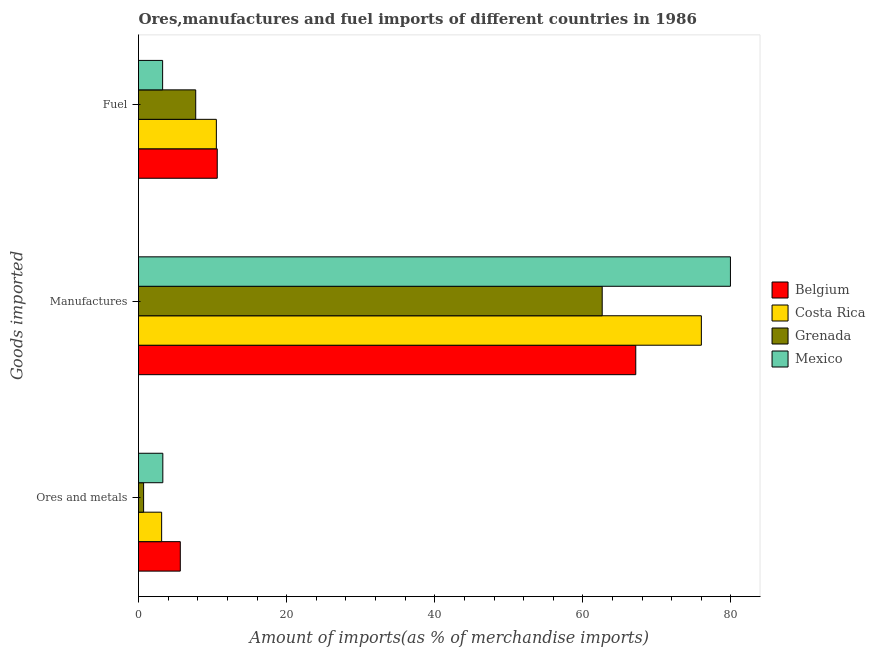Are the number of bars per tick equal to the number of legend labels?
Your response must be concise. Yes. How many bars are there on the 3rd tick from the top?
Provide a succinct answer. 4. How many bars are there on the 3rd tick from the bottom?
Your answer should be very brief. 4. What is the label of the 3rd group of bars from the top?
Keep it short and to the point. Ores and metals. What is the percentage of manufactures imports in Mexico?
Your answer should be very brief. 79.93. Across all countries, what is the maximum percentage of ores and metals imports?
Your answer should be very brief. 5.64. Across all countries, what is the minimum percentage of fuel imports?
Ensure brevity in your answer.  3.26. In which country was the percentage of fuel imports maximum?
Provide a succinct answer. Belgium. What is the total percentage of ores and metals imports in the graph?
Ensure brevity in your answer.  12.74. What is the difference between the percentage of ores and metals imports in Costa Rica and that in Grenada?
Make the answer very short. 2.44. What is the difference between the percentage of fuel imports in Belgium and the percentage of ores and metals imports in Mexico?
Offer a very short reply. 7.35. What is the average percentage of manufactures imports per country?
Offer a terse response. 71.42. What is the difference between the percentage of ores and metals imports and percentage of manufactures imports in Belgium?
Your answer should be compact. -61.5. In how many countries, is the percentage of ores and metals imports greater than 56 %?
Provide a short and direct response. 0. What is the ratio of the percentage of manufactures imports in Costa Rica to that in Belgium?
Your response must be concise. 1.13. Is the percentage of manufactures imports in Mexico less than that in Costa Rica?
Provide a short and direct response. No. Is the difference between the percentage of fuel imports in Belgium and Grenada greater than the difference between the percentage of manufactures imports in Belgium and Grenada?
Ensure brevity in your answer.  No. What is the difference between the highest and the second highest percentage of manufactures imports?
Offer a very short reply. 3.93. What is the difference between the highest and the lowest percentage of fuel imports?
Your response must be concise. 7.38. What does the 4th bar from the top in Manufactures represents?
Your answer should be compact. Belgium. How many countries are there in the graph?
Ensure brevity in your answer.  4. What is the difference between two consecutive major ticks on the X-axis?
Your response must be concise. 20. Are the values on the major ticks of X-axis written in scientific E-notation?
Provide a succinct answer. No. Does the graph contain any zero values?
Your answer should be compact. No. Where does the legend appear in the graph?
Make the answer very short. Center right. How many legend labels are there?
Provide a short and direct response. 4. What is the title of the graph?
Your answer should be compact. Ores,manufactures and fuel imports of different countries in 1986. Does "Liberia" appear as one of the legend labels in the graph?
Your answer should be very brief. No. What is the label or title of the X-axis?
Keep it short and to the point. Amount of imports(as % of merchandise imports). What is the label or title of the Y-axis?
Make the answer very short. Goods imported. What is the Amount of imports(as % of merchandise imports) of Belgium in Ores and metals?
Your answer should be compact. 5.64. What is the Amount of imports(as % of merchandise imports) in Costa Rica in Ores and metals?
Offer a very short reply. 3.12. What is the Amount of imports(as % of merchandise imports) of Grenada in Ores and metals?
Your response must be concise. 0.69. What is the Amount of imports(as % of merchandise imports) of Mexico in Ores and metals?
Ensure brevity in your answer.  3.28. What is the Amount of imports(as % of merchandise imports) of Belgium in Manufactures?
Provide a succinct answer. 67.14. What is the Amount of imports(as % of merchandise imports) of Costa Rica in Manufactures?
Give a very brief answer. 76. What is the Amount of imports(as % of merchandise imports) in Grenada in Manufactures?
Offer a very short reply. 62.61. What is the Amount of imports(as % of merchandise imports) in Mexico in Manufactures?
Your answer should be very brief. 79.93. What is the Amount of imports(as % of merchandise imports) in Belgium in Fuel?
Ensure brevity in your answer.  10.63. What is the Amount of imports(as % of merchandise imports) in Costa Rica in Fuel?
Give a very brief answer. 10.51. What is the Amount of imports(as % of merchandise imports) in Grenada in Fuel?
Give a very brief answer. 7.72. What is the Amount of imports(as % of merchandise imports) of Mexico in Fuel?
Your answer should be very brief. 3.26. Across all Goods imported, what is the maximum Amount of imports(as % of merchandise imports) of Belgium?
Your response must be concise. 67.14. Across all Goods imported, what is the maximum Amount of imports(as % of merchandise imports) of Costa Rica?
Make the answer very short. 76. Across all Goods imported, what is the maximum Amount of imports(as % of merchandise imports) in Grenada?
Provide a short and direct response. 62.61. Across all Goods imported, what is the maximum Amount of imports(as % of merchandise imports) of Mexico?
Your answer should be compact. 79.93. Across all Goods imported, what is the minimum Amount of imports(as % of merchandise imports) of Belgium?
Your answer should be compact. 5.64. Across all Goods imported, what is the minimum Amount of imports(as % of merchandise imports) in Costa Rica?
Your answer should be very brief. 3.12. Across all Goods imported, what is the minimum Amount of imports(as % of merchandise imports) in Grenada?
Offer a terse response. 0.69. Across all Goods imported, what is the minimum Amount of imports(as % of merchandise imports) in Mexico?
Provide a short and direct response. 3.26. What is the total Amount of imports(as % of merchandise imports) in Belgium in the graph?
Offer a terse response. 83.42. What is the total Amount of imports(as % of merchandise imports) of Costa Rica in the graph?
Offer a very short reply. 89.64. What is the total Amount of imports(as % of merchandise imports) of Grenada in the graph?
Keep it short and to the point. 71.02. What is the total Amount of imports(as % of merchandise imports) of Mexico in the graph?
Offer a very short reply. 86.47. What is the difference between the Amount of imports(as % of merchandise imports) of Belgium in Ores and metals and that in Manufactures?
Provide a succinct answer. -61.5. What is the difference between the Amount of imports(as % of merchandise imports) in Costa Rica in Ores and metals and that in Manufactures?
Keep it short and to the point. -72.87. What is the difference between the Amount of imports(as % of merchandise imports) in Grenada in Ores and metals and that in Manufactures?
Your answer should be very brief. -61.92. What is the difference between the Amount of imports(as % of merchandise imports) in Mexico in Ores and metals and that in Manufactures?
Provide a succinct answer. -76.64. What is the difference between the Amount of imports(as % of merchandise imports) of Belgium in Ores and metals and that in Fuel?
Your answer should be very brief. -4.99. What is the difference between the Amount of imports(as % of merchandise imports) in Costa Rica in Ores and metals and that in Fuel?
Provide a short and direct response. -7.39. What is the difference between the Amount of imports(as % of merchandise imports) in Grenada in Ores and metals and that in Fuel?
Offer a terse response. -7.04. What is the difference between the Amount of imports(as % of merchandise imports) of Mexico in Ores and metals and that in Fuel?
Your answer should be compact. 0.03. What is the difference between the Amount of imports(as % of merchandise imports) of Belgium in Manufactures and that in Fuel?
Provide a short and direct response. 56.51. What is the difference between the Amount of imports(as % of merchandise imports) in Costa Rica in Manufactures and that in Fuel?
Offer a very short reply. 65.49. What is the difference between the Amount of imports(as % of merchandise imports) of Grenada in Manufactures and that in Fuel?
Ensure brevity in your answer.  54.89. What is the difference between the Amount of imports(as % of merchandise imports) of Mexico in Manufactures and that in Fuel?
Make the answer very short. 76.67. What is the difference between the Amount of imports(as % of merchandise imports) in Belgium in Ores and metals and the Amount of imports(as % of merchandise imports) in Costa Rica in Manufactures?
Your answer should be very brief. -70.36. What is the difference between the Amount of imports(as % of merchandise imports) in Belgium in Ores and metals and the Amount of imports(as % of merchandise imports) in Grenada in Manufactures?
Your answer should be compact. -56.97. What is the difference between the Amount of imports(as % of merchandise imports) of Belgium in Ores and metals and the Amount of imports(as % of merchandise imports) of Mexico in Manufactures?
Ensure brevity in your answer.  -74.28. What is the difference between the Amount of imports(as % of merchandise imports) in Costa Rica in Ores and metals and the Amount of imports(as % of merchandise imports) in Grenada in Manufactures?
Make the answer very short. -59.49. What is the difference between the Amount of imports(as % of merchandise imports) in Costa Rica in Ores and metals and the Amount of imports(as % of merchandise imports) in Mexico in Manufactures?
Offer a very short reply. -76.8. What is the difference between the Amount of imports(as % of merchandise imports) of Grenada in Ores and metals and the Amount of imports(as % of merchandise imports) of Mexico in Manufactures?
Make the answer very short. -79.24. What is the difference between the Amount of imports(as % of merchandise imports) of Belgium in Ores and metals and the Amount of imports(as % of merchandise imports) of Costa Rica in Fuel?
Provide a succinct answer. -4.87. What is the difference between the Amount of imports(as % of merchandise imports) of Belgium in Ores and metals and the Amount of imports(as % of merchandise imports) of Grenada in Fuel?
Provide a succinct answer. -2.08. What is the difference between the Amount of imports(as % of merchandise imports) of Belgium in Ores and metals and the Amount of imports(as % of merchandise imports) of Mexico in Fuel?
Your response must be concise. 2.39. What is the difference between the Amount of imports(as % of merchandise imports) in Costa Rica in Ores and metals and the Amount of imports(as % of merchandise imports) in Grenada in Fuel?
Make the answer very short. -4.6. What is the difference between the Amount of imports(as % of merchandise imports) in Costa Rica in Ores and metals and the Amount of imports(as % of merchandise imports) in Mexico in Fuel?
Provide a succinct answer. -0.13. What is the difference between the Amount of imports(as % of merchandise imports) of Grenada in Ores and metals and the Amount of imports(as % of merchandise imports) of Mexico in Fuel?
Ensure brevity in your answer.  -2.57. What is the difference between the Amount of imports(as % of merchandise imports) of Belgium in Manufactures and the Amount of imports(as % of merchandise imports) of Costa Rica in Fuel?
Offer a very short reply. 56.63. What is the difference between the Amount of imports(as % of merchandise imports) in Belgium in Manufactures and the Amount of imports(as % of merchandise imports) in Grenada in Fuel?
Your answer should be compact. 59.42. What is the difference between the Amount of imports(as % of merchandise imports) of Belgium in Manufactures and the Amount of imports(as % of merchandise imports) of Mexico in Fuel?
Offer a terse response. 63.89. What is the difference between the Amount of imports(as % of merchandise imports) in Costa Rica in Manufactures and the Amount of imports(as % of merchandise imports) in Grenada in Fuel?
Keep it short and to the point. 68.27. What is the difference between the Amount of imports(as % of merchandise imports) in Costa Rica in Manufactures and the Amount of imports(as % of merchandise imports) in Mexico in Fuel?
Your response must be concise. 72.74. What is the difference between the Amount of imports(as % of merchandise imports) of Grenada in Manufactures and the Amount of imports(as % of merchandise imports) of Mexico in Fuel?
Provide a succinct answer. 59.35. What is the average Amount of imports(as % of merchandise imports) of Belgium per Goods imported?
Ensure brevity in your answer.  27.81. What is the average Amount of imports(as % of merchandise imports) of Costa Rica per Goods imported?
Your answer should be very brief. 29.88. What is the average Amount of imports(as % of merchandise imports) in Grenada per Goods imported?
Keep it short and to the point. 23.67. What is the average Amount of imports(as % of merchandise imports) of Mexico per Goods imported?
Give a very brief answer. 28.82. What is the difference between the Amount of imports(as % of merchandise imports) of Belgium and Amount of imports(as % of merchandise imports) of Costa Rica in Ores and metals?
Offer a very short reply. 2.52. What is the difference between the Amount of imports(as % of merchandise imports) of Belgium and Amount of imports(as % of merchandise imports) of Grenada in Ores and metals?
Give a very brief answer. 4.95. What is the difference between the Amount of imports(as % of merchandise imports) in Belgium and Amount of imports(as % of merchandise imports) in Mexico in Ores and metals?
Provide a succinct answer. 2.36. What is the difference between the Amount of imports(as % of merchandise imports) in Costa Rica and Amount of imports(as % of merchandise imports) in Grenada in Ores and metals?
Provide a succinct answer. 2.44. What is the difference between the Amount of imports(as % of merchandise imports) in Costa Rica and Amount of imports(as % of merchandise imports) in Mexico in Ores and metals?
Your response must be concise. -0.16. What is the difference between the Amount of imports(as % of merchandise imports) of Grenada and Amount of imports(as % of merchandise imports) of Mexico in Ores and metals?
Your response must be concise. -2.6. What is the difference between the Amount of imports(as % of merchandise imports) of Belgium and Amount of imports(as % of merchandise imports) of Costa Rica in Manufactures?
Make the answer very short. -8.86. What is the difference between the Amount of imports(as % of merchandise imports) in Belgium and Amount of imports(as % of merchandise imports) in Grenada in Manufactures?
Provide a succinct answer. 4.53. What is the difference between the Amount of imports(as % of merchandise imports) of Belgium and Amount of imports(as % of merchandise imports) of Mexico in Manufactures?
Your answer should be compact. -12.78. What is the difference between the Amount of imports(as % of merchandise imports) of Costa Rica and Amount of imports(as % of merchandise imports) of Grenada in Manufactures?
Your answer should be very brief. 13.39. What is the difference between the Amount of imports(as % of merchandise imports) in Costa Rica and Amount of imports(as % of merchandise imports) in Mexico in Manufactures?
Ensure brevity in your answer.  -3.93. What is the difference between the Amount of imports(as % of merchandise imports) in Grenada and Amount of imports(as % of merchandise imports) in Mexico in Manufactures?
Give a very brief answer. -17.32. What is the difference between the Amount of imports(as % of merchandise imports) in Belgium and Amount of imports(as % of merchandise imports) in Costa Rica in Fuel?
Your answer should be very brief. 0.12. What is the difference between the Amount of imports(as % of merchandise imports) of Belgium and Amount of imports(as % of merchandise imports) of Grenada in Fuel?
Your response must be concise. 2.91. What is the difference between the Amount of imports(as % of merchandise imports) of Belgium and Amount of imports(as % of merchandise imports) of Mexico in Fuel?
Offer a terse response. 7.38. What is the difference between the Amount of imports(as % of merchandise imports) in Costa Rica and Amount of imports(as % of merchandise imports) in Grenada in Fuel?
Your answer should be compact. 2.79. What is the difference between the Amount of imports(as % of merchandise imports) in Costa Rica and Amount of imports(as % of merchandise imports) in Mexico in Fuel?
Provide a succinct answer. 7.26. What is the difference between the Amount of imports(as % of merchandise imports) in Grenada and Amount of imports(as % of merchandise imports) in Mexico in Fuel?
Ensure brevity in your answer.  4.47. What is the ratio of the Amount of imports(as % of merchandise imports) in Belgium in Ores and metals to that in Manufactures?
Give a very brief answer. 0.08. What is the ratio of the Amount of imports(as % of merchandise imports) in Costa Rica in Ores and metals to that in Manufactures?
Keep it short and to the point. 0.04. What is the ratio of the Amount of imports(as % of merchandise imports) of Grenada in Ores and metals to that in Manufactures?
Provide a succinct answer. 0.01. What is the ratio of the Amount of imports(as % of merchandise imports) in Mexico in Ores and metals to that in Manufactures?
Provide a succinct answer. 0.04. What is the ratio of the Amount of imports(as % of merchandise imports) of Belgium in Ores and metals to that in Fuel?
Provide a succinct answer. 0.53. What is the ratio of the Amount of imports(as % of merchandise imports) in Costa Rica in Ores and metals to that in Fuel?
Make the answer very short. 0.3. What is the ratio of the Amount of imports(as % of merchandise imports) in Grenada in Ores and metals to that in Fuel?
Ensure brevity in your answer.  0.09. What is the ratio of the Amount of imports(as % of merchandise imports) of Mexico in Ores and metals to that in Fuel?
Your answer should be very brief. 1.01. What is the ratio of the Amount of imports(as % of merchandise imports) of Belgium in Manufactures to that in Fuel?
Provide a short and direct response. 6.31. What is the ratio of the Amount of imports(as % of merchandise imports) in Costa Rica in Manufactures to that in Fuel?
Ensure brevity in your answer.  7.23. What is the ratio of the Amount of imports(as % of merchandise imports) of Grenada in Manufactures to that in Fuel?
Keep it short and to the point. 8.11. What is the ratio of the Amount of imports(as % of merchandise imports) of Mexico in Manufactures to that in Fuel?
Give a very brief answer. 24.54. What is the difference between the highest and the second highest Amount of imports(as % of merchandise imports) of Belgium?
Ensure brevity in your answer.  56.51. What is the difference between the highest and the second highest Amount of imports(as % of merchandise imports) in Costa Rica?
Keep it short and to the point. 65.49. What is the difference between the highest and the second highest Amount of imports(as % of merchandise imports) in Grenada?
Offer a very short reply. 54.89. What is the difference between the highest and the second highest Amount of imports(as % of merchandise imports) in Mexico?
Keep it short and to the point. 76.64. What is the difference between the highest and the lowest Amount of imports(as % of merchandise imports) in Belgium?
Provide a short and direct response. 61.5. What is the difference between the highest and the lowest Amount of imports(as % of merchandise imports) of Costa Rica?
Ensure brevity in your answer.  72.87. What is the difference between the highest and the lowest Amount of imports(as % of merchandise imports) in Grenada?
Your answer should be compact. 61.92. What is the difference between the highest and the lowest Amount of imports(as % of merchandise imports) in Mexico?
Keep it short and to the point. 76.67. 